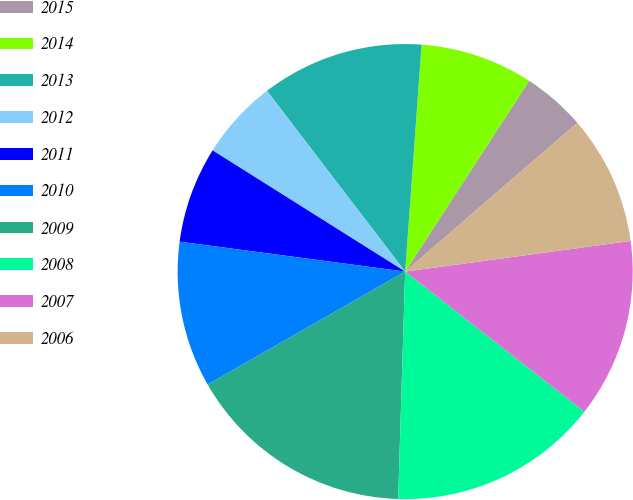Convert chart to OTSL. <chart><loc_0><loc_0><loc_500><loc_500><pie_chart><fcel>2015<fcel>2014<fcel>2013<fcel>2012<fcel>2011<fcel>2010<fcel>2009<fcel>2008<fcel>2007<fcel>2006<nl><fcel>4.49%<fcel>8.02%<fcel>11.54%<fcel>5.67%<fcel>6.84%<fcel>10.37%<fcel>16.24%<fcel>14.93%<fcel>12.71%<fcel>9.19%<nl></chart> 